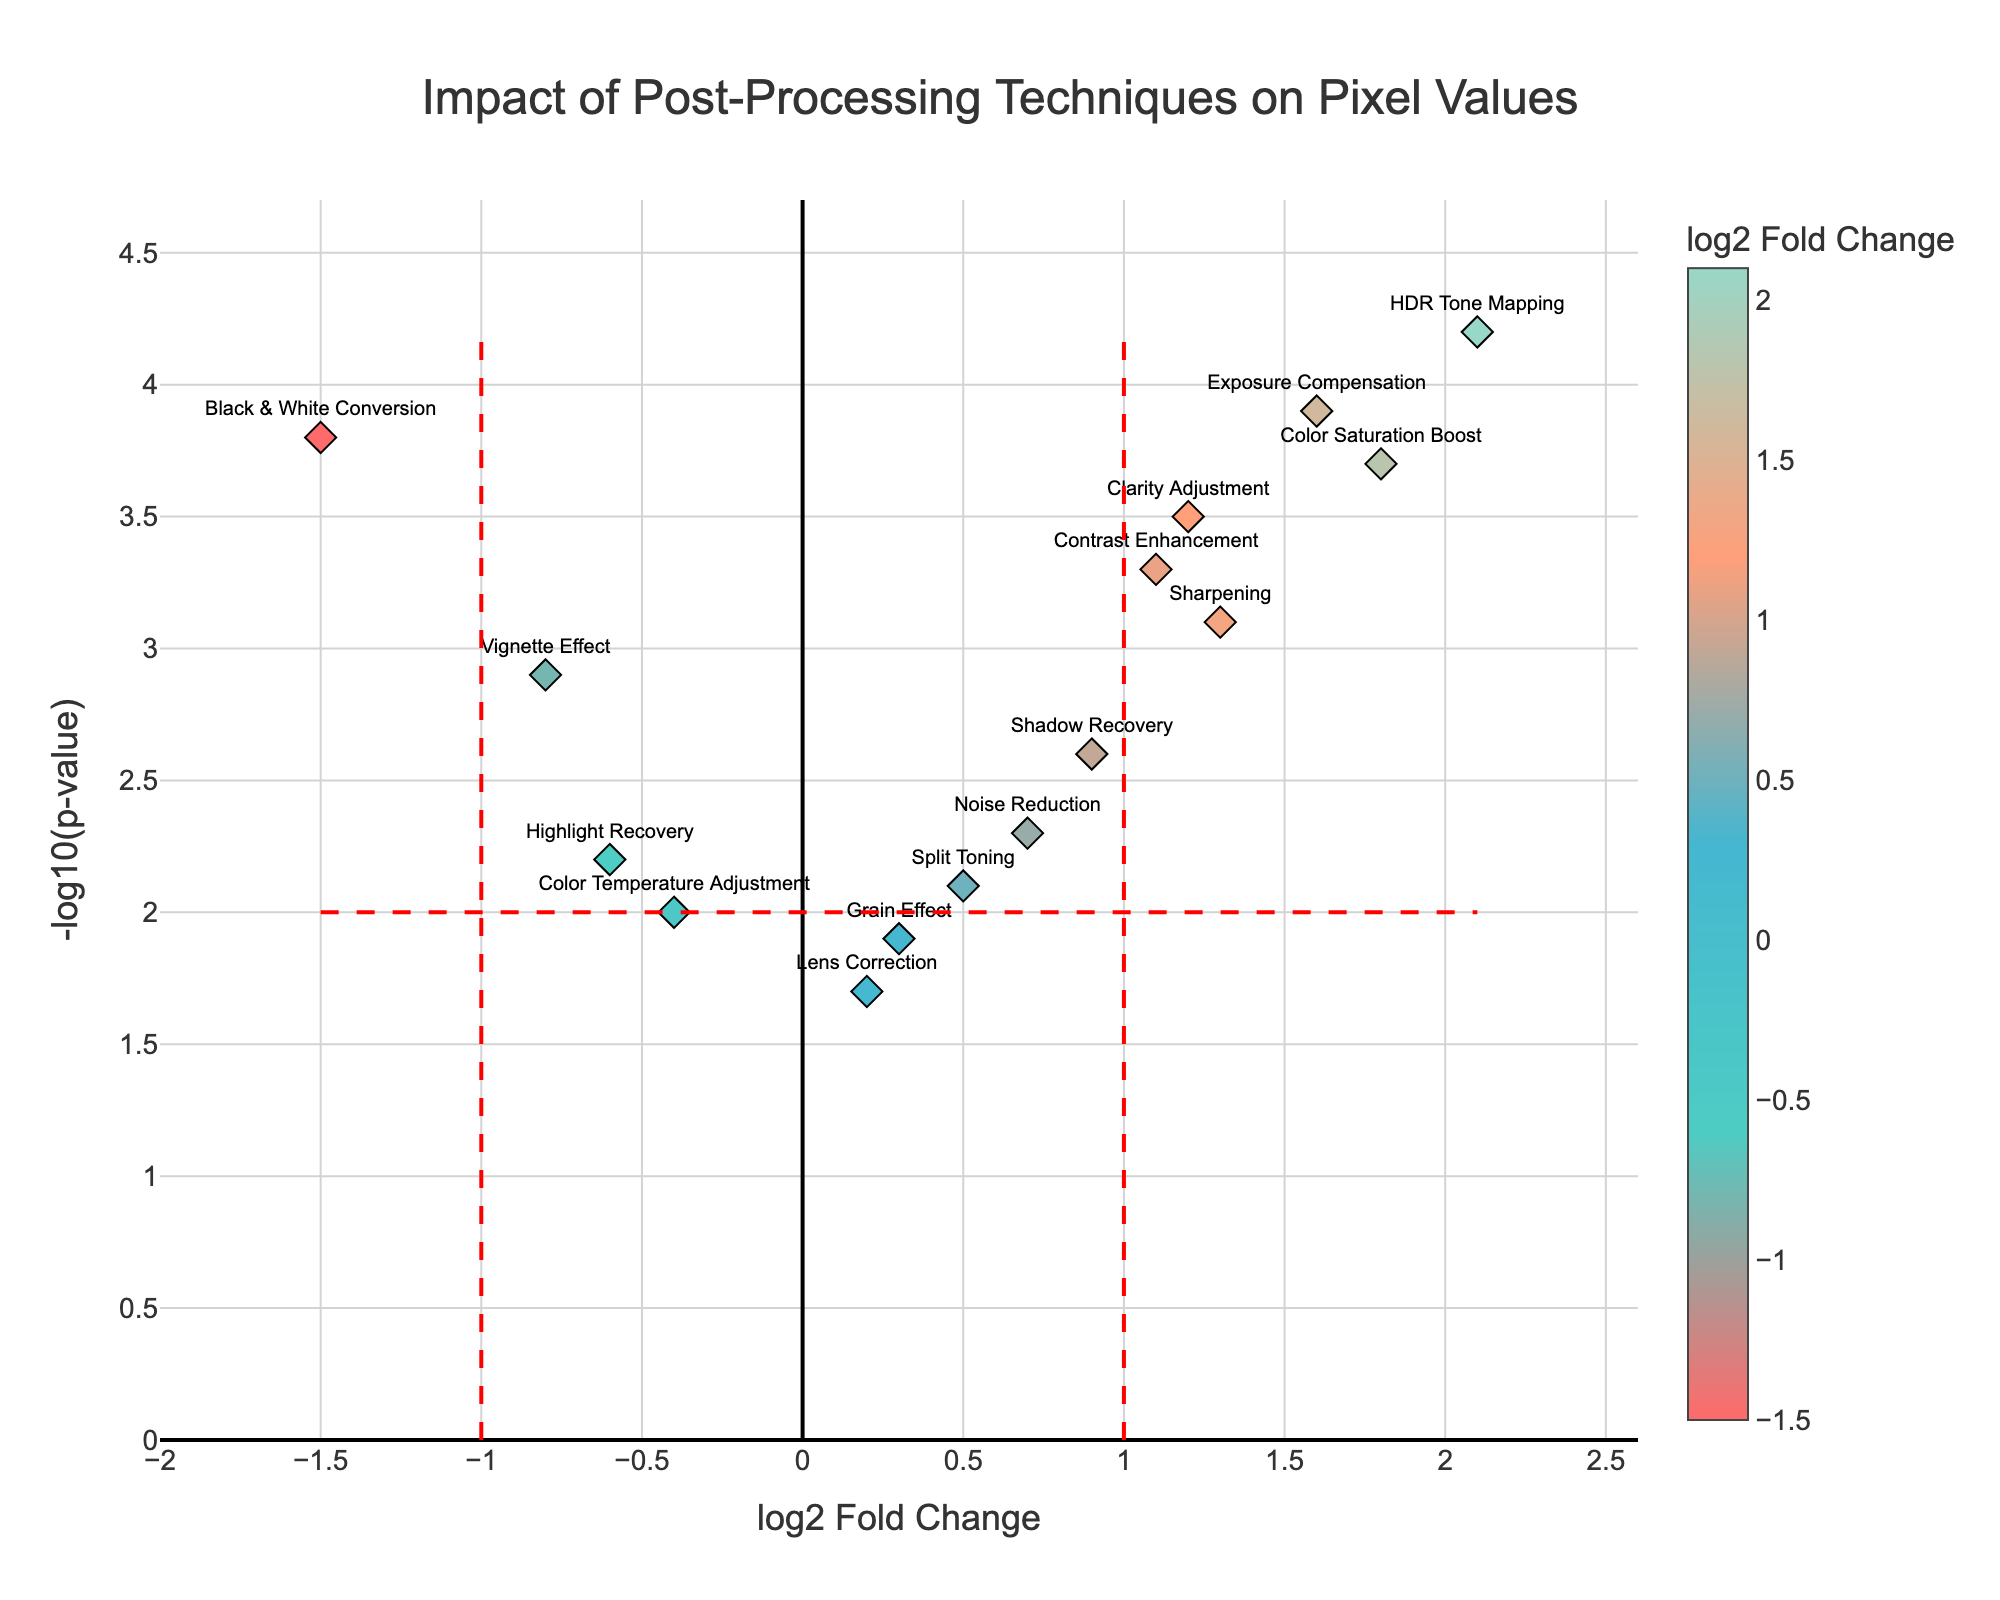What is the title of the plot? The title is located at the top center of the plot and describes the theme of the figure. The title helps set the context for interpreting the data.
Answer: Impact of Post-Processing Techniques on Pixel Values Which technique has the highest log2 fold change? The highest log2 fold change is the largest value along the x-axis, where the data point is farthest to the right. From the plot, it is the data point labeled "HDR Tone Mapping."
Answer: HDR Tone Mapping How many techniques have a negative log2 fold change? Negative log2 fold changes correspond to data points to the left of the vertical y-axis. Count these data points from the left side of the axis.
Answer: 6 What is the significance threshold for the p-value in the plot? The significance threshold is shown by the horizontal red dashed line, which represents the -log10(p-value). The p-value corresponding to the threshold is provided at y=2.
Answer: 2 Which technique has the highest significance (lowest p-value)? The highest significance corresponds to the largest -log10(p-value), which is the data point highest on the y-axis. This is "HDR Tone Mapping" with the highest value.
Answer: HDR Tone Mapping Which technique has the lowest log2 fold change combined with a higher significance than the threshold? Look for the data point farthest to the left (lowest log2 fold change) above the horizontal threshold line. "Black & White Conversion" fits this description.
Answer: Black & White Conversion Compare the log2 fold change of "Color Saturation Boost" and "Exposure Compensation." Which one is higher? Identify both data points on the plot and compare their x-axis (log2 fold change) values. "Color Saturation Boost" has a log2 fold change of 1.8, whereas "Exposure Compensation" has 1.6.
Answer: Color Saturation Boost What is the log2 fold change and -log10(p-value) for "Sharpening"? Find the "Sharpening" data point and read the coordinates from the plot. The log2 fold change is the x-coordinate, and the -log10(p-value) is the y-coordinate.
Answer: 1.3 and 3.1 What is the average log2 fold change of "Color Saturation Boost," "Sharpening," and "Contrast Enhancement"? Add the log2 fold changes of these techniques and divide by the number of techniques: (1.8 + 1.3 + 1.1) / 3.
Answer: 1.4 Of the techniques "Vignette Effect," "Shadow Recovery," and "Highlight Recovery," which has the highest significance? Compare the -log10(p-value) values of these techniques by locating their positions on the y-axis and selecting the highest one.
Answer: Vignette Effect 